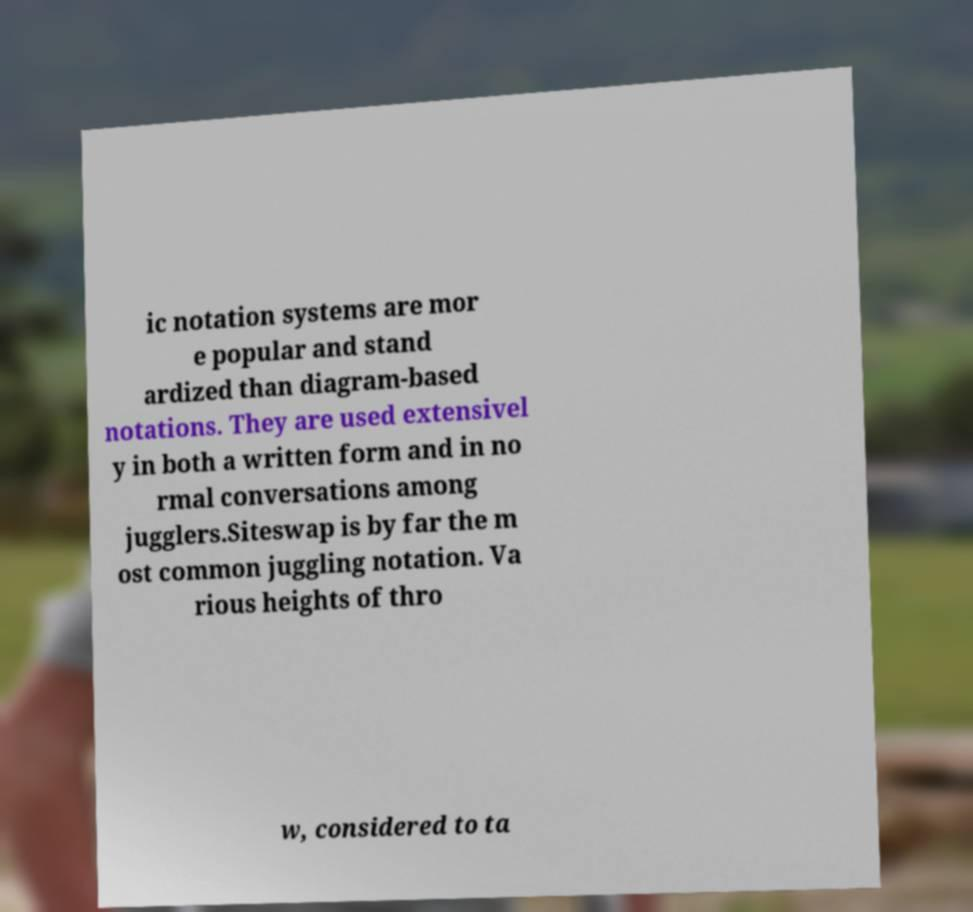What messages or text are displayed in this image? I need them in a readable, typed format. ic notation systems are mor e popular and stand ardized than diagram-based notations. They are used extensivel y in both a written form and in no rmal conversations among jugglers.Siteswap is by far the m ost common juggling notation. Va rious heights of thro w, considered to ta 